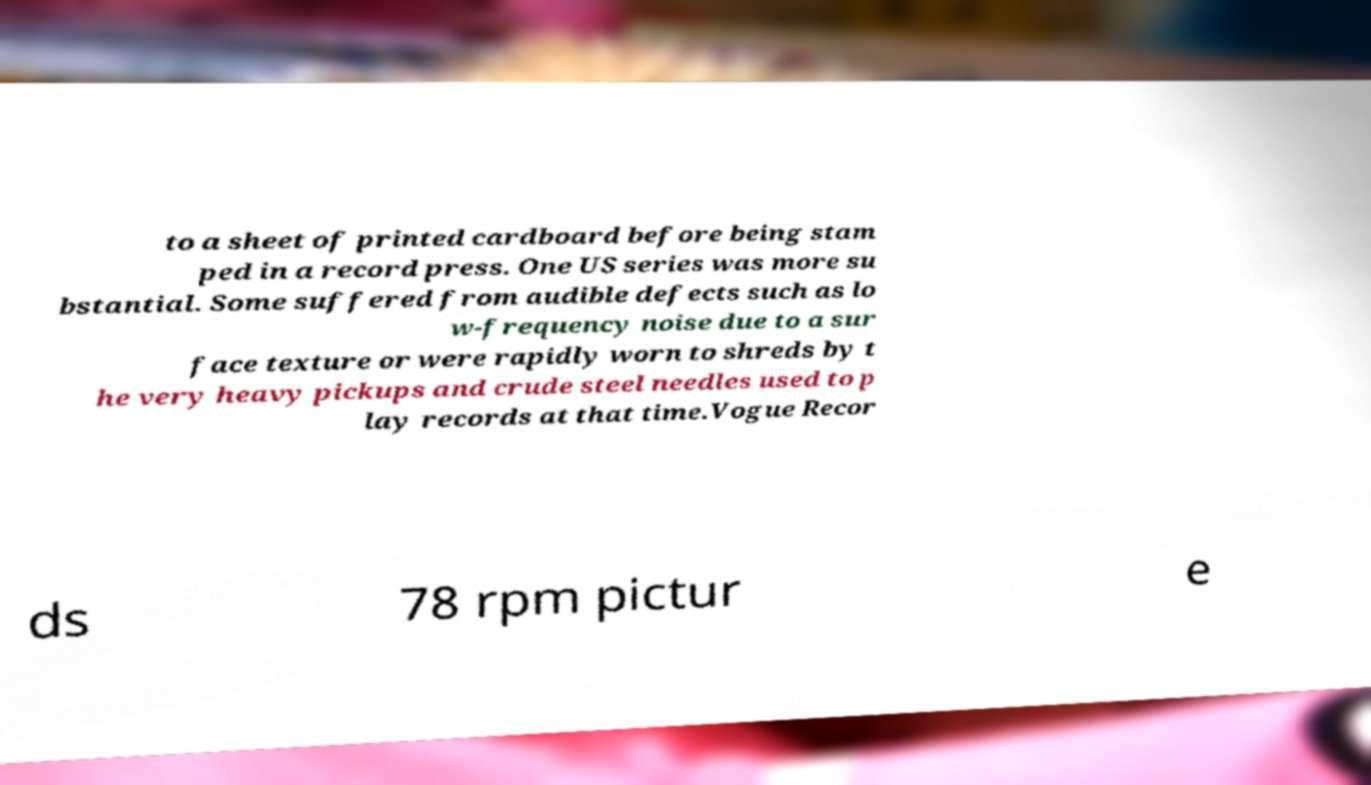Please read and relay the text visible in this image. What does it say? to a sheet of printed cardboard before being stam ped in a record press. One US series was more su bstantial. Some suffered from audible defects such as lo w-frequency noise due to a sur face texture or were rapidly worn to shreds by t he very heavy pickups and crude steel needles used to p lay records at that time.Vogue Recor ds 78 rpm pictur e 